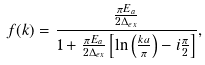Convert formula to latex. <formula><loc_0><loc_0><loc_500><loc_500>f ( k ) = \frac { \frac { \pi E _ { a } } { 2 \Delta _ { e x } } } { 1 + \frac { \pi E _ { a } } { 2 \Delta _ { e x } } \left [ \ln \left ( \frac { k a } { \pi } \right ) - i \frac { \pi } { 2 } \right ] } ,</formula> 